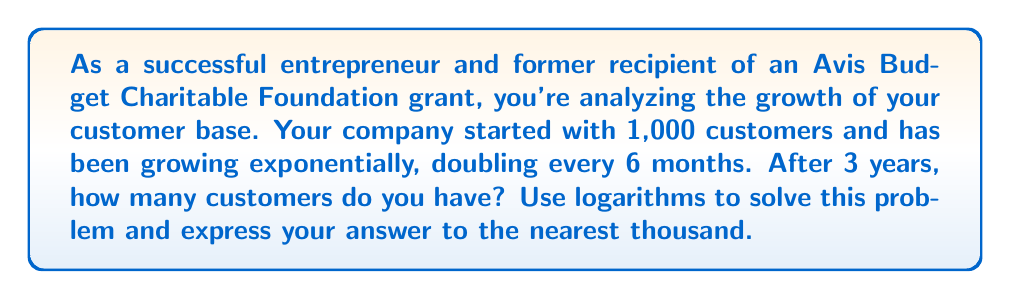Solve this math problem. Let's approach this step-by-step using logarithms:

1) First, let's define our variables:
   $N_0 = 1,000$ (initial number of customers)
   $t = 3$ years
   $r = 2$ (growth factor per period)
   $n = 6$ (number of periods in 3 years)

2) The general formula for exponential growth is:
   $N = N_0 \cdot r^n$

3) We need to find $n$:
   In 3 years, there are 6 periods of 6 months each, so $n = 6$

4) Now we can plug in our values:
   $N = 1,000 \cdot 2^6$

5) To solve this, we can use logarithms:
   $\log N = \log(1,000 \cdot 2^6)$
   $\log N = \log 1,000 + 6 \log 2$

6) Using the properties of logarithms:
   $\log 1,000 = 3$ (since $10^3 = 1,000$)
   $\log 2 \approx 0.301$

7) Substituting:
   $\log N = 3 + 6 \cdot 0.301 = 3 + 1.806 = 4.806$

8) To find N, we use the inverse function:
   $N = 10^{4.806} \approx 63,968$

9) Rounding to the nearest thousand:
   $N \approx 64,000$
Answer: 64,000 customers 